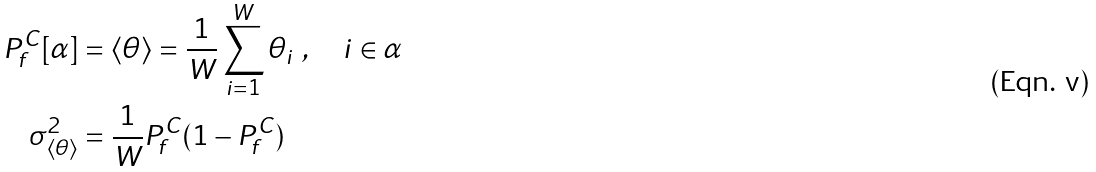Convert formula to latex. <formula><loc_0><loc_0><loc_500><loc_500>P _ { f } ^ { C } [ \alpha ] & = \langle \theta \rangle = \frac { 1 } { W } \sum _ { i = 1 } ^ { W } \theta _ { i } \ , \quad i \in \alpha \\ \sigma ^ { 2 } _ { \left < \theta \right > } & = \frac { 1 } { W } P _ { f } ^ { C } ( 1 - P _ { f } ^ { C } )</formula> 